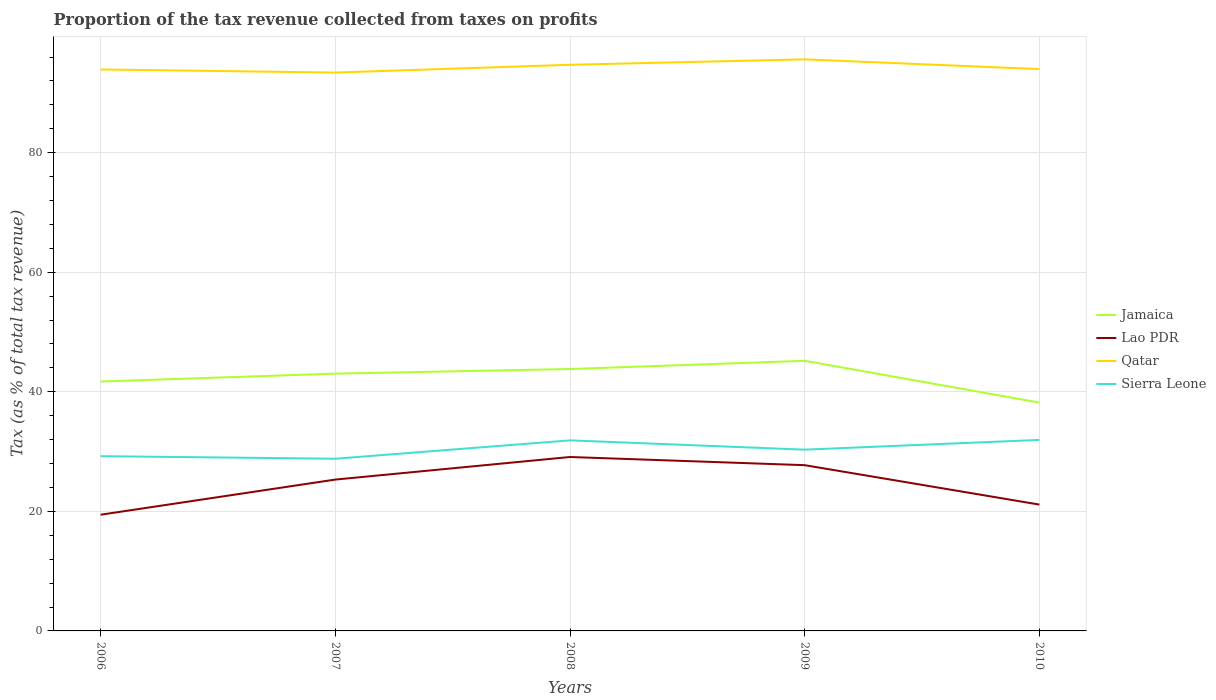Does the line corresponding to Sierra Leone intersect with the line corresponding to Qatar?
Your answer should be very brief. No. Across all years, what is the maximum proportion of the tax revenue collected in Jamaica?
Provide a short and direct response. 38.2. In which year was the proportion of the tax revenue collected in Qatar maximum?
Your response must be concise. 2007. What is the total proportion of the tax revenue collected in Qatar in the graph?
Provide a short and direct response. -0.78. What is the difference between the highest and the second highest proportion of the tax revenue collected in Qatar?
Provide a short and direct response. 2.21. What is the difference between the highest and the lowest proportion of the tax revenue collected in Qatar?
Make the answer very short. 2. Is the proportion of the tax revenue collected in Sierra Leone strictly greater than the proportion of the tax revenue collected in Lao PDR over the years?
Offer a very short reply. No. How many years are there in the graph?
Give a very brief answer. 5. Does the graph contain any zero values?
Give a very brief answer. No. Does the graph contain grids?
Ensure brevity in your answer.  Yes. Where does the legend appear in the graph?
Your answer should be very brief. Center right. How many legend labels are there?
Keep it short and to the point. 4. How are the legend labels stacked?
Offer a very short reply. Vertical. What is the title of the graph?
Your answer should be very brief. Proportion of the tax revenue collected from taxes on profits. Does "Ethiopia" appear as one of the legend labels in the graph?
Provide a succinct answer. No. What is the label or title of the Y-axis?
Ensure brevity in your answer.  Tax (as % of total tax revenue). What is the Tax (as % of total tax revenue) of Jamaica in 2006?
Give a very brief answer. 41.72. What is the Tax (as % of total tax revenue) of Lao PDR in 2006?
Provide a short and direct response. 19.44. What is the Tax (as % of total tax revenue) in Qatar in 2006?
Your response must be concise. 93.92. What is the Tax (as % of total tax revenue) in Sierra Leone in 2006?
Keep it short and to the point. 29.23. What is the Tax (as % of total tax revenue) in Jamaica in 2007?
Your response must be concise. 43.04. What is the Tax (as % of total tax revenue) in Lao PDR in 2007?
Keep it short and to the point. 25.32. What is the Tax (as % of total tax revenue) of Qatar in 2007?
Provide a succinct answer. 93.4. What is the Tax (as % of total tax revenue) in Sierra Leone in 2007?
Your answer should be compact. 28.8. What is the Tax (as % of total tax revenue) of Jamaica in 2008?
Give a very brief answer. 43.81. What is the Tax (as % of total tax revenue) of Lao PDR in 2008?
Offer a terse response. 29.09. What is the Tax (as % of total tax revenue) of Qatar in 2008?
Your answer should be compact. 94.7. What is the Tax (as % of total tax revenue) in Sierra Leone in 2008?
Your response must be concise. 31.87. What is the Tax (as % of total tax revenue) of Jamaica in 2009?
Ensure brevity in your answer.  45.18. What is the Tax (as % of total tax revenue) of Lao PDR in 2009?
Give a very brief answer. 27.72. What is the Tax (as % of total tax revenue) of Qatar in 2009?
Your response must be concise. 95.61. What is the Tax (as % of total tax revenue) of Sierra Leone in 2009?
Ensure brevity in your answer.  30.32. What is the Tax (as % of total tax revenue) of Jamaica in 2010?
Make the answer very short. 38.2. What is the Tax (as % of total tax revenue) of Lao PDR in 2010?
Your answer should be very brief. 21.13. What is the Tax (as % of total tax revenue) of Qatar in 2010?
Offer a terse response. 93.98. What is the Tax (as % of total tax revenue) of Sierra Leone in 2010?
Make the answer very short. 31.95. Across all years, what is the maximum Tax (as % of total tax revenue) in Jamaica?
Provide a succinct answer. 45.18. Across all years, what is the maximum Tax (as % of total tax revenue) of Lao PDR?
Your answer should be very brief. 29.09. Across all years, what is the maximum Tax (as % of total tax revenue) in Qatar?
Ensure brevity in your answer.  95.61. Across all years, what is the maximum Tax (as % of total tax revenue) of Sierra Leone?
Provide a short and direct response. 31.95. Across all years, what is the minimum Tax (as % of total tax revenue) of Jamaica?
Your response must be concise. 38.2. Across all years, what is the minimum Tax (as % of total tax revenue) in Lao PDR?
Keep it short and to the point. 19.44. Across all years, what is the minimum Tax (as % of total tax revenue) of Qatar?
Your answer should be compact. 93.4. Across all years, what is the minimum Tax (as % of total tax revenue) in Sierra Leone?
Offer a terse response. 28.8. What is the total Tax (as % of total tax revenue) of Jamaica in the graph?
Give a very brief answer. 211.95. What is the total Tax (as % of total tax revenue) of Lao PDR in the graph?
Keep it short and to the point. 122.71. What is the total Tax (as % of total tax revenue) of Qatar in the graph?
Keep it short and to the point. 471.61. What is the total Tax (as % of total tax revenue) in Sierra Leone in the graph?
Your answer should be very brief. 152.18. What is the difference between the Tax (as % of total tax revenue) of Jamaica in 2006 and that in 2007?
Give a very brief answer. -1.31. What is the difference between the Tax (as % of total tax revenue) of Lao PDR in 2006 and that in 2007?
Keep it short and to the point. -5.88. What is the difference between the Tax (as % of total tax revenue) in Qatar in 2006 and that in 2007?
Provide a succinct answer. 0.52. What is the difference between the Tax (as % of total tax revenue) in Sierra Leone in 2006 and that in 2007?
Offer a very short reply. 0.43. What is the difference between the Tax (as % of total tax revenue) in Jamaica in 2006 and that in 2008?
Provide a short and direct response. -2.09. What is the difference between the Tax (as % of total tax revenue) in Lao PDR in 2006 and that in 2008?
Offer a very short reply. -9.66. What is the difference between the Tax (as % of total tax revenue) in Qatar in 2006 and that in 2008?
Provide a succinct answer. -0.78. What is the difference between the Tax (as % of total tax revenue) in Sierra Leone in 2006 and that in 2008?
Your answer should be very brief. -2.64. What is the difference between the Tax (as % of total tax revenue) of Jamaica in 2006 and that in 2009?
Provide a succinct answer. -3.46. What is the difference between the Tax (as % of total tax revenue) of Lao PDR in 2006 and that in 2009?
Keep it short and to the point. -8.29. What is the difference between the Tax (as % of total tax revenue) in Qatar in 2006 and that in 2009?
Ensure brevity in your answer.  -1.69. What is the difference between the Tax (as % of total tax revenue) in Sierra Leone in 2006 and that in 2009?
Offer a terse response. -1.09. What is the difference between the Tax (as % of total tax revenue) in Jamaica in 2006 and that in 2010?
Provide a short and direct response. 3.53. What is the difference between the Tax (as % of total tax revenue) in Lao PDR in 2006 and that in 2010?
Provide a succinct answer. -1.69. What is the difference between the Tax (as % of total tax revenue) in Qatar in 2006 and that in 2010?
Offer a very short reply. -0.06. What is the difference between the Tax (as % of total tax revenue) of Sierra Leone in 2006 and that in 2010?
Give a very brief answer. -2.72. What is the difference between the Tax (as % of total tax revenue) in Jamaica in 2007 and that in 2008?
Give a very brief answer. -0.77. What is the difference between the Tax (as % of total tax revenue) in Lao PDR in 2007 and that in 2008?
Make the answer very short. -3.78. What is the difference between the Tax (as % of total tax revenue) in Sierra Leone in 2007 and that in 2008?
Provide a short and direct response. -3.07. What is the difference between the Tax (as % of total tax revenue) in Jamaica in 2007 and that in 2009?
Your response must be concise. -2.15. What is the difference between the Tax (as % of total tax revenue) in Lao PDR in 2007 and that in 2009?
Your response must be concise. -2.41. What is the difference between the Tax (as % of total tax revenue) of Qatar in 2007 and that in 2009?
Provide a succinct answer. -2.21. What is the difference between the Tax (as % of total tax revenue) of Sierra Leone in 2007 and that in 2009?
Offer a very short reply. -1.52. What is the difference between the Tax (as % of total tax revenue) in Jamaica in 2007 and that in 2010?
Make the answer very short. 4.84. What is the difference between the Tax (as % of total tax revenue) of Lao PDR in 2007 and that in 2010?
Offer a very short reply. 4.19. What is the difference between the Tax (as % of total tax revenue) of Qatar in 2007 and that in 2010?
Make the answer very short. -0.58. What is the difference between the Tax (as % of total tax revenue) of Sierra Leone in 2007 and that in 2010?
Your answer should be compact. -3.15. What is the difference between the Tax (as % of total tax revenue) in Jamaica in 2008 and that in 2009?
Provide a short and direct response. -1.37. What is the difference between the Tax (as % of total tax revenue) in Lao PDR in 2008 and that in 2009?
Offer a very short reply. 1.37. What is the difference between the Tax (as % of total tax revenue) in Qatar in 2008 and that in 2009?
Make the answer very short. -0.91. What is the difference between the Tax (as % of total tax revenue) of Sierra Leone in 2008 and that in 2009?
Your answer should be very brief. 1.55. What is the difference between the Tax (as % of total tax revenue) of Jamaica in 2008 and that in 2010?
Make the answer very short. 5.61. What is the difference between the Tax (as % of total tax revenue) in Lao PDR in 2008 and that in 2010?
Provide a succinct answer. 7.96. What is the difference between the Tax (as % of total tax revenue) of Qatar in 2008 and that in 2010?
Give a very brief answer. 0.72. What is the difference between the Tax (as % of total tax revenue) in Sierra Leone in 2008 and that in 2010?
Keep it short and to the point. -0.08. What is the difference between the Tax (as % of total tax revenue) of Jamaica in 2009 and that in 2010?
Your answer should be compact. 6.99. What is the difference between the Tax (as % of total tax revenue) of Lao PDR in 2009 and that in 2010?
Offer a terse response. 6.59. What is the difference between the Tax (as % of total tax revenue) in Qatar in 2009 and that in 2010?
Give a very brief answer. 1.63. What is the difference between the Tax (as % of total tax revenue) of Sierra Leone in 2009 and that in 2010?
Your response must be concise. -1.63. What is the difference between the Tax (as % of total tax revenue) of Jamaica in 2006 and the Tax (as % of total tax revenue) of Lao PDR in 2007?
Your answer should be compact. 16.4. What is the difference between the Tax (as % of total tax revenue) of Jamaica in 2006 and the Tax (as % of total tax revenue) of Qatar in 2007?
Make the answer very short. -51.68. What is the difference between the Tax (as % of total tax revenue) in Jamaica in 2006 and the Tax (as % of total tax revenue) in Sierra Leone in 2007?
Give a very brief answer. 12.92. What is the difference between the Tax (as % of total tax revenue) in Lao PDR in 2006 and the Tax (as % of total tax revenue) in Qatar in 2007?
Provide a short and direct response. -73.96. What is the difference between the Tax (as % of total tax revenue) of Lao PDR in 2006 and the Tax (as % of total tax revenue) of Sierra Leone in 2007?
Provide a succinct answer. -9.36. What is the difference between the Tax (as % of total tax revenue) in Qatar in 2006 and the Tax (as % of total tax revenue) in Sierra Leone in 2007?
Offer a very short reply. 65.11. What is the difference between the Tax (as % of total tax revenue) of Jamaica in 2006 and the Tax (as % of total tax revenue) of Lao PDR in 2008?
Keep it short and to the point. 12.63. What is the difference between the Tax (as % of total tax revenue) of Jamaica in 2006 and the Tax (as % of total tax revenue) of Qatar in 2008?
Make the answer very short. -52.98. What is the difference between the Tax (as % of total tax revenue) of Jamaica in 2006 and the Tax (as % of total tax revenue) of Sierra Leone in 2008?
Keep it short and to the point. 9.85. What is the difference between the Tax (as % of total tax revenue) in Lao PDR in 2006 and the Tax (as % of total tax revenue) in Qatar in 2008?
Give a very brief answer. -75.26. What is the difference between the Tax (as % of total tax revenue) in Lao PDR in 2006 and the Tax (as % of total tax revenue) in Sierra Leone in 2008?
Keep it short and to the point. -12.44. What is the difference between the Tax (as % of total tax revenue) in Qatar in 2006 and the Tax (as % of total tax revenue) in Sierra Leone in 2008?
Give a very brief answer. 62.04. What is the difference between the Tax (as % of total tax revenue) of Jamaica in 2006 and the Tax (as % of total tax revenue) of Lao PDR in 2009?
Provide a succinct answer. 14. What is the difference between the Tax (as % of total tax revenue) in Jamaica in 2006 and the Tax (as % of total tax revenue) in Qatar in 2009?
Your answer should be compact. -53.89. What is the difference between the Tax (as % of total tax revenue) of Jamaica in 2006 and the Tax (as % of total tax revenue) of Sierra Leone in 2009?
Offer a very short reply. 11.4. What is the difference between the Tax (as % of total tax revenue) of Lao PDR in 2006 and the Tax (as % of total tax revenue) of Qatar in 2009?
Your answer should be compact. -76.17. What is the difference between the Tax (as % of total tax revenue) in Lao PDR in 2006 and the Tax (as % of total tax revenue) in Sierra Leone in 2009?
Ensure brevity in your answer.  -10.88. What is the difference between the Tax (as % of total tax revenue) of Qatar in 2006 and the Tax (as % of total tax revenue) of Sierra Leone in 2009?
Your answer should be compact. 63.6. What is the difference between the Tax (as % of total tax revenue) in Jamaica in 2006 and the Tax (as % of total tax revenue) in Lao PDR in 2010?
Offer a very short reply. 20.59. What is the difference between the Tax (as % of total tax revenue) in Jamaica in 2006 and the Tax (as % of total tax revenue) in Qatar in 2010?
Make the answer very short. -52.26. What is the difference between the Tax (as % of total tax revenue) of Jamaica in 2006 and the Tax (as % of total tax revenue) of Sierra Leone in 2010?
Give a very brief answer. 9.77. What is the difference between the Tax (as % of total tax revenue) in Lao PDR in 2006 and the Tax (as % of total tax revenue) in Qatar in 2010?
Your answer should be very brief. -74.54. What is the difference between the Tax (as % of total tax revenue) in Lao PDR in 2006 and the Tax (as % of total tax revenue) in Sierra Leone in 2010?
Keep it short and to the point. -12.51. What is the difference between the Tax (as % of total tax revenue) of Qatar in 2006 and the Tax (as % of total tax revenue) of Sierra Leone in 2010?
Offer a very short reply. 61.96. What is the difference between the Tax (as % of total tax revenue) in Jamaica in 2007 and the Tax (as % of total tax revenue) in Lao PDR in 2008?
Offer a very short reply. 13.94. What is the difference between the Tax (as % of total tax revenue) in Jamaica in 2007 and the Tax (as % of total tax revenue) in Qatar in 2008?
Provide a succinct answer. -51.66. What is the difference between the Tax (as % of total tax revenue) of Jamaica in 2007 and the Tax (as % of total tax revenue) of Sierra Leone in 2008?
Provide a succinct answer. 11.16. What is the difference between the Tax (as % of total tax revenue) of Lao PDR in 2007 and the Tax (as % of total tax revenue) of Qatar in 2008?
Make the answer very short. -69.38. What is the difference between the Tax (as % of total tax revenue) in Lao PDR in 2007 and the Tax (as % of total tax revenue) in Sierra Leone in 2008?
Offer a terse response. -6.56. What is the difference between the Tax (as % of total tax revenue) in Qatar in 2007 and the Tax (as % of total tax revenue) in Sierra Leone in 2008?
Your response must be concise. 61.53. What is the difference between the Tax (as % of total tax revenue) in Jamaica in 2007 and the Tax (as % of total tax revenue) in Lao PDR in 2009?
Keep it short and to the point. 15.31. What is the difference between the Tax (as % of total tax revenue) in Jamaica in 2007 and the Tax (as % of total tax revenue) in Qatar in 2009?
Make the answer very short. -52.57. What is the difference between the Tax (as % of total tax revenue) of Jamaica in 2007 and the Tax (as % of total tax revenue) of Sierra Leone in 2009?
Your answer should be very brief. 12.72. What is the difference between the Tax (as % of total tax revenue) of Lao PDR in 2007 and the Tax (as % of total tax revenue) of Qatar in 2009?
Keep it short and to the point. -70.29. What is the difference between the Tax (as % of total tax revenue) of Lao PDR in 2007 and the Tax (as % of total tax revenue) of Sierra Leone in 2009?
Your answer should be very brief. -5. What is the difference between the Tax (as % of total tax revenue) in Qatar in 2007 and the Tax (as % of total tax revenue) in Sierra Leone in 2009?
Provide a short and direct response. 63.08. What is the difference between the Tax (as % of total tax revenue) in Jamaica in 2007 and the Tax (as % of total tax revenue) in Lao PDR in 2010?
Your answer should be very brief. 21.9. What is the difference between the Tax (as % of total tax revenue) of Jamaica in 2007 and the Tax (as % of total tax revenue) of Qatar in 2010?
Make the answer very short. -50.94. What is the difference between the Tax (as % of total tax revenue) in Jamaica in 2007 and the Tax (as % of total tax revenue) in Sierra Leone in 2010?
Provide a short and direct response. 11.08. What is the difference between the Tax (as % of total tax revenue) of Lao PDR in 2007 and the Tax (as % of total tax revenue) of Qatar in 2010?
Keep it short and to the point. -68.66. What is the difference between the Tax (as % of total tax revenue) of Lao PDR in 2007 and the Tax (as % of total tax revenue) of Sierra Leone in 2010?
Offer a terse response. -6.64. What is the difference between the Tax (as % of total tax revenue) of Qatar in 2007 and the Tax (as % of total tax revenue) of Sierra Leone in 2010?
Give a very brief answer. 61.45. What is the difference between the Tax (as % of total tax revenue) of Jamaica in 2008 and the Tax (as % of total tax revenue) of Lao PDR in 2009?
Your answer should be very brief. 16.09. What is the difference between the Tax (as % of total tax revenue) of Jamaica in 2008 and the Tax (as % of total tax revenue) of Qatar in 2009?
Ensure brevity in your answer.  -51.8. What is the difference between the Tax (as % of total tax revenue) in Jamaica in 2008 and the Tax (as % of total tax revenue) in Sierra Leone in 2009?
Keep it short and to the point. 13.49. What is the difference between the Tax (as % of total tax revenue) in Lao PDR in 2008 and the Tax (as % of total tax revenue) in Qatar in 2009?
Offer a very short reply. -66.52. What is the difference between the Tax (as % of total tax revenue) of Lao PDR in 2008 and the Tax (as % of total tax revenue) of Sierra Leone in 2009?
Ensure brevity in your answer.  -1.23. What is the difference between the Tax (as % of total tax revenue) of Qatar in 2008 and the Tax (as % of total tax revenue) of Sierra Leone in 2009?
Offer a terse response. 64.38. What is the difference between the Tax (as % of total tax revenue) of Jamaica in 2008 and the Tax (as % of total tax revenue) of Lao PDR in 2010?
Your answer should be compact. 22.68. What is the difference between the Tax (as % of total tax revenue) in Jamaica in 2008 and the Tax (as % of total tax revenue) in Qatar in 2010?
Make the answer very short. -50.17. What is the difference between the Tax (as % of total tax revenue) of Jamaica in 2008 and the Tax (as % of total tax revenue) of Sierra Leone in 2010?
Make the answer very short. 11.86. What is the difference between the Tax (as % of total tax revenue) of Lao PDR in 2008 and the Tax (as % of total tax revenue) of Qatar in 2010?
Your response must be concise. -64.89. What is the difference between the Tax (as % of total tax revenue) in Lao PDR in 2008 and the Tax (as % of total tax revenue) in Sierra Leone in 2010?
Provide a succinct answer. -2.86. What is the difference between the Tax (as % of total tax revenue) in Qatar in 2008 and the Tax (as % of total tax revenue) in Sierra Leone in 2010?
Offer a very short reply. 62.75. What is the difference between the Tax (as % of total tax revenue) of Jamaica in 2009 and the Tax (as % of total tax revenue) of Lao PDR in 2010?
Keep it short and to the point. 24.05. What is the difference between the Tax (as % of total tax revenue) of Jamaica in 2009 and the Tax (as % of total tax revenue) of Qatar in 2010?
Give a very brief answer. -48.8. What is the difference between the Tax (as % of total tax revenue) in Jamaica in 2009 and the Tax (as % of total tax revenue) in Sierra Leone in 2010?
Ensure brevity in your answer.  13.23. What is the difference between the Tax (as % of total tax revenue) in Lao PDR in 2009 and the Tax (as % of total tax revenue) in Qatar in 2010?
Ensure brevity in your answer.  -66.25. What is the difference between the Tax (as % of total tax revenue) in Lao PDR in 2009 and the Tax (as % of total tax revenue) in Sierra Leone in 2010?
Provide a short and direct response. -4.23. What is the difference between the Tax (as % of total tax revenue) of Qatar in 2009 and the Tax (as % of total tax revenue) of Sierra Leone in 2010?
Provide a short and direct response. 63.66. What is the average Tax (as % of total tax revenue) of Jamaica per year?
Offer a terse response. 42.39. What is the average Tax (as % of total tax revenue) of Lao PDR per year?
Give a very brief answer. 24.54. What is the average Tax (as % of total tax revenue) of Qatar per year?
Offer a very short reply. 94.32. What is the average Tax (as % of total tax revenue) of Sierra Leone per year?
Your response must be concise. 30.44. In the year 2006, what is the difference between the Tax (as % of total tax revenue) of Jamaica and Tax (as % of total tax revenue) of Lao PDR?
Ensure brevity in your answer.  22.28. In the year 2006, what is the difference between the Tax (as % of total tax revenue) of Jamaica and Tax (as % of total tax revenue) of Qatar?
Provide a succinct answer. -52.2. In the year 2006, what is the difference between the Tax (as % of total tax revenue) of Jamaica and Tax (as % of total tax revenue) of Sierra Leone?
Your answer should be very brief. 12.49. In the year 2006, what is the difference between the Tax (as % of total tax revenue) in Lao PDR and Tax (as % of total tax revenue) in Qatar?
Your answer should be very brief. -74.48. In the year 2006, what is the difference between the Tax (as % of total tax revenue) of Lao PDR and Tax (as % of total tax revenue) of Sierra Leone?
Your answer should be very brief. -9.8. In the year 2006, what is the difference between the Tax (as % of total tax revenue) in Qatar and Tax (as % of total tax revenue) in Sierra Leone?
Provide a short and direct response. 64.68. In the year 2007, what is the difference between the Tax (as % of total tax revenue) in Jamaica and Tax (as % of total tax revenue) in Lao PDR?
Offer a terse response. 17.72. In the year 2007, what is the difference between the Tax (as % of total tax revenue) of Jamaica and Tax (as % of total tax revenue) of Qatar?
Your response must be concise. -50.36. In the year 2007, what is the difference between the Tax (as % of total tax revenue) in Jamaica and Tax (as % of total tax revenue) in Sierra Leone?
Your answer should be very brief. 14.23. In the year 2007, what is the difference between the Tax (as % of total tax revenue) of Lao PDR and Tax (as % of total tax revenue) of Qatar?
Make the answer very short. -68.08. In the year 2007, what is the difference between the Tax (as % of total tax revenue) of Lao PDR and Tax (as % of total tax revenue) of Sierra Leone?
Your answer should be compact. -3.48. In the year 2007, what is the difference between the Tax (as % of total tax revenue) in Qatar and Tax (as % of total tax revenue) in Sierra Leone?
Your response must be concise. 64.6. In the year 2008, what is the difference between the Tax (as % of total tax revenue) in Jamaica and Tax (as % of total tax revenue) in Lao PDR?
Make the answer very short. 14.72. In the year 2008, what is the difference between the Tax (as % of total tax revenue) in Jamaica and Tax (as % of total tax revenue) in Qatar?
Make the answer very short. -50.89. In the year 2008, what is the difference between the Tax (as % of total tax revenue) of Jamaica and Tax (as % of total tax revenue) of Sierra Leone?
Make the answer very short. 11.94. In the year 2008, what is the difference between the Tax (as % of total tax revenue) in Lao PDR and Tax (as % of total tax revenue) in Qatar?
Make the answer very short. -65.61. In the year 2008, what is the difference between the Tax (as % of total tax revenue) of Lao PDR and Tax (as % of total tax revenue) of Sierra Leone?
Give a very brief answer. -2.78. In the year 2008, what is the difference between the Tax (as % of total tax revenue) of Qatar and Tax (as % of total tax revenue) of Sierra Leone?
Your response must be concise. 62.83. In the year 2009, what is the difference between the Tax (as % of total tax revenue) in Jamaica and Tax (as % of total tax revenue) in Lao PDR?
Your answer should be very brief. 17.46. In the year 2009, what is the difference between the Tax (as % of total tax revenue) of Jamaica and Tax (as % of total tax revenue) of Qatar?
Your answer should be very brief. -50.43. In the year 2009, what is the difference between the Tax (as % of total tax revenue) of Jamaica and Tax (as % of total tax revenue) of Sierra Leone?
Make the answer very short. 14.86. In the year 2009, what is the difference between the Tax (as % of total tax revenue) of Lao PDR and Tax (as % of total tax revenue) of Qatar?
Keep it short and to the point. -67.89. In the year 2009, what is the difference between the Tax (as % of total tax revenue) of Lao PDR and Tax (as % of total tax revenue) of Sierra Leone?
Ensure brevity in your answer.  -2.6. In the year 2009, what is the difference between the Tax (as % of total tax revenue) in Qatar and Tax (as % of total tax revenue) in Sierra Leone?
Offer a very short reply. 65.29. In the year 2010, what is the difference between the Tax (as % of total tax revenue) of Jamaica and Tax (as % of total tax revenue) of Lao PDR?
Your answer should be compact. 17.06. In the year 2010, what is the difference between the Tax (as % of total tax revenue) of Jamaica and Tax (as % of total tax revenue) of Qatar?
Your response must be concise. -55.78. In the year 2010, what is the difference between the Tax (as % of total tax revenue) in Jamaica and Tax (as % of total tax revenue) in Sierra Leone?
Give a very brief answer. 6.24. In the year 2010, what is the difference between the Tax (as % of total tax revenue) of Lao PDR and Tax (as % of total tax revenue) of Qatar?
Keep it short and to the point. -72.85. In the year 2010, what is the difference between the Tax (as % of total tax revenue) in Lao PDR and Tax (as % of total tax revenue) in Sierra Leone?
Offer a very short reply. -10.82. In the year 2010, what is the difference between the Tax (as % of total tax revenue) of Qatar and Tax (as % of total tax revenue) of Sierra Leone?
Offer a very short reply. 62.03. What is the ratio of the Tax (as % of total tax revenue) in Jamaica in 2006 to that in 2007?
Give a very brief answer. 0.97. What is the ratio of the Tax (as % of total tax revenue) in Lao PDR in 2006 to that in 2007?
Make the answer very short. 0.77. What is the ratio of the Tax (as % of total tax revenue) in Qatar in 2006 to that in 2007?
Your answer should be compact. 1.01. What is the ratio of the Tax (as % of total tax revenue) of Jamaica in 2006 to that in 2008?
Offer a very short reply. 0.95. What is the ratio of the Tax (as % of total tax revenue) of Lao PDR in 2006 to that in 2008?
Give a very brief answer. 0.67. What is the ratio of the Tax (as % of total tax revenue) of Sierra Leone in 2006 to that in 2008?
Your answer should be very brief. 0.92. What is the ratio of the Tax (as % of total tax revenue) in Jamaica in 2006 to that in 2009?
Your answer should be very brief. 0.92. What is the ratio of the Tax (as % of total tax revenue) in Lao PDR in 2006 to that in 2009?
Your answer should be compact. 0.7. What is the ratio of the Tax (as % of total tax revenue) in Qatar in 2006 to that in 2009?
Offer a terse response. 0.98. What is the ratio of the Tax (as % of total tax revenue) in Sierra Leone in 2006 to that in 2009?
Make the answer very short. 0.96. What is the ratio of the Tax (as % of total tax revenue) in Jamaica in 2006 to that in 2010?
Give a very brief answer. 1.09. What is the ratio of the Tax (as % of total tax revenue) of Lao PDR in 2006 to that in 2010?
Your answer should be very brief. 0.92. What is the ratio of the Tax (as % of total tax revenue) in Qatar in 2006 to that in 2010?
Your answer should be very brief. 1. What is the ratio of the Tax (as % of total tax revenue) in Sierra Leone in 2006 to that in 2010?
Ensure brevity in your answer.  0.91. What is the ratio of the Tax (as % of total tax revenue) in Jamaica in 2007 to that in 2008?
Give a very brief answer. 0.98. What is the ratio of the Tax (as % of total tax revenue) in Lao PDR in 2007 to that in 2008?
Offer a terse response. 0.87. What is the ratio of the Tax (as % of total tax revenue) of Qatar in 2007 to that in 2008?
Provide a short and direct response. 0.99. What is the ratio of the Tax (as % of total tax revenue) in Sierra Leone in 2007 to that in 2008?
Your answer should be very brief. 0.9. What is the ratio of the Tax (as % of total tax revenue) of Jamaica in 2007 to that in 2009?
Provide a succinct answer. 0.95. What is the ratio of the Tax (as % of total tax revenue) in Lao PDR in 2007 to that in 2009?
Offer a terse response. 0.91. What is the ratio of the Tax (as % of total tax revenue) in Qatar in 2007 to that in 2009?
Ensure brevity in your answer.  0.98. What is the ratio of the Tax (as % of total tax revenue) in Sierra Leone in 2007 to that in 2009?
Offer a terse response. 0.95. What is the ratio of the Tax (as % of total tax revenue) in Jamaica in 2007 to that in 2010?
Your answer should be compact. 1.13. What is the ratio of the Tax (as % of total tax revenue) of Lao PDR in 2007 to that in 2010?
Provide a succinct answer. 1.2. What is the ratio of the Tax (as % of total tax revenue) of Qatar in 2007 to that in 2010?
Your answer should be very brief. 0.99. What is the ratio of the Tax (as % of total tax revenue) in Sierra Leone in 2007 to that in 2010?
Provide a short and direct response. 0.9. What is the ratio of the Tax (as % of total tax revenue) in Jamaica in 2008 to that in 2009?
Offer a very short reply. 0.97. What is the ratio of the Tax (as % of total tax revenue) of Lao PDR in 2008 to that in 2009?
Give a very brief answer. 1.05. What is the ratio of the Tax (as % of total tax revenue) in Qatar in 2008 to that in 2009?
Your answer should be very brief. 0.99. What is the ratio of the Tax (as % of total tax revenue) of Sierra Leone in 2008 to that in 2009?
Offer a very short reply. 1.05. What is the ratio of the Tax (as % of total tax revenue) in Jamaica in 2008 to that in 2010?
Ensure brevity in your answer.  1.15. What is the ratio of the Tax (as % of total tax revenue) in Lao PDR in 2008 to that in 2010?
Ensure brevity in your answer.  1.38. What is the ratio of the Tax (as % of total tax revenue) of Qatar in 2008 to that in 2010?
Your response must be concise. 1.01. What is the ratio of the Tax (as % of total tax revenue) in Jamaica in 2009 to that in 2010?
Offer a very short reply. 1.18. What is the ratio of the Tax (as % of total tax revenue) in Lao PDR in 2009 to that in 2010?
Offer a terse response. 1.31. What is the ratio of the Tax (as % of total tax revenue) of Qatar in 2009 to that in 2010?
Provide a succinct answer. 1.02. What is the ratio of the Tax (as % of total tax revenue) in Sierra Leone in 2009 to that in 2010?
Provide a succinct answer. 0.95. What is the difference between the highest and the second highest Tax (as % of total tax revenue) in Jamaica?
Your answer should be very brief. 1.37. What is the difference between the highest and the second highest Tax (as % of total tax revenue) in Lao PDR?
Make the answer very short. 1.37. What is the difference between the highest and the second highest Tax (as % of total tax revenue) in Qatar?
Provide a succinct answer. 0.91. What is the difference between the highest and the second highest Tax (as % of total tax revenue) in Sierra Leone?
Keep it short and to the point. 0.08. What is the difference between the highest and the lowest Tax (as % of total tax revenue) in Jamaica?
Provide a short and direct response. 6.99. What is the difference between the highest and the lowest Tax (as % of total tax revenue) of Lao PDR?
Your response must be concise. 9.66. What is the difference between the highest and the lowest Tax (as % of total tax revenue) in Qatar?
Offer a terse response. 2.21. What is the difference between the highest and the lowest Tax (as % of total tax revenue) of Sierra Leone?
Your response must be concise. 3.15. 